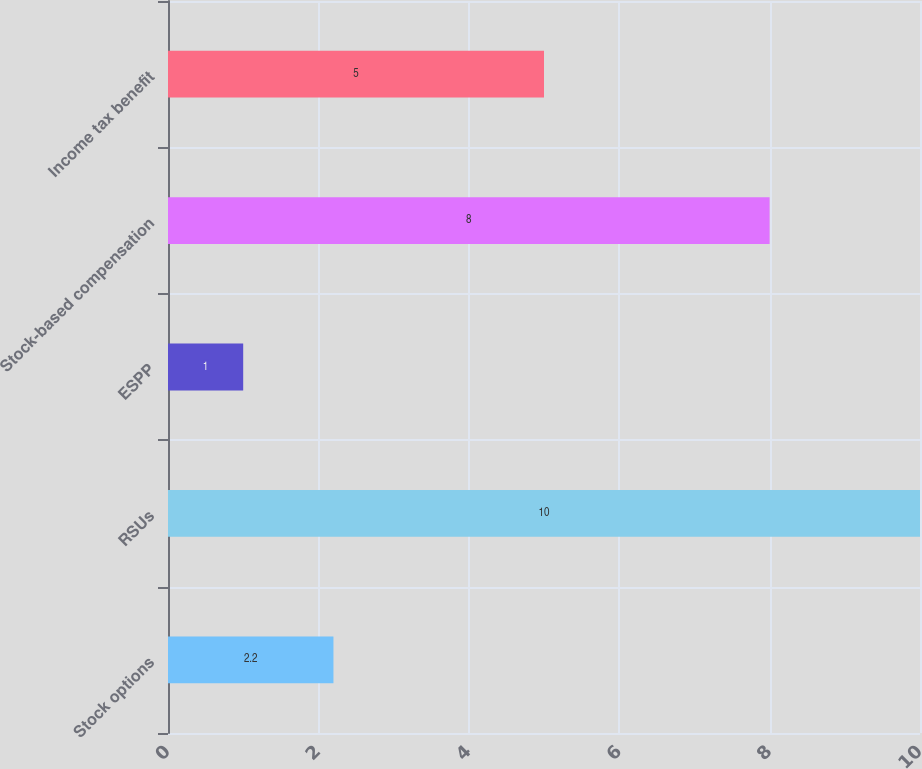<chart> <loc_0><loc_0><loc_500><loc_500><bar_chart><fcel>Stock options<fcel>RSUs<fcel>ESPP<fcel>Stock-based compensation<fcel>Income tax benefit<nl><fcel>2.2<fcel>10<fcel>1<fcel>8<fcel>5<nl></chart> 